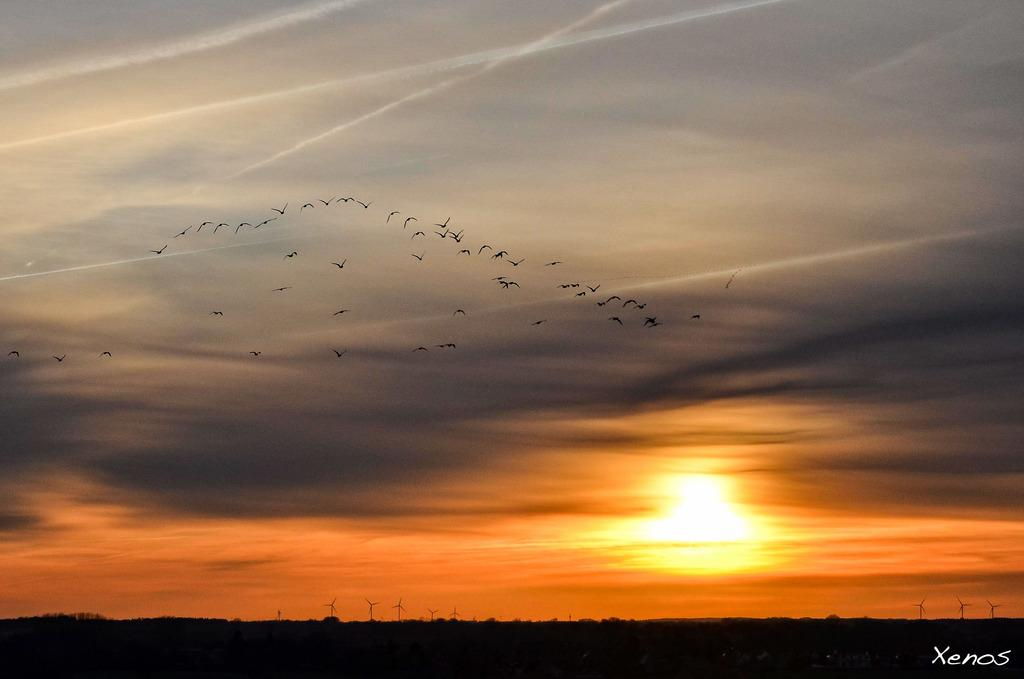Where is the sun located in the image? The sun is visible at the bottom of the image. What structures can be seen in the image? There are windmills in the image. What type of animals are present in the image? Birds are present in the image. What is visible at the top of the image? The sky is visible at the top of the image. What type of paper is being used by the windmills in the image? There is no paper present in the image, and the windmills do not use paper for their operation. 